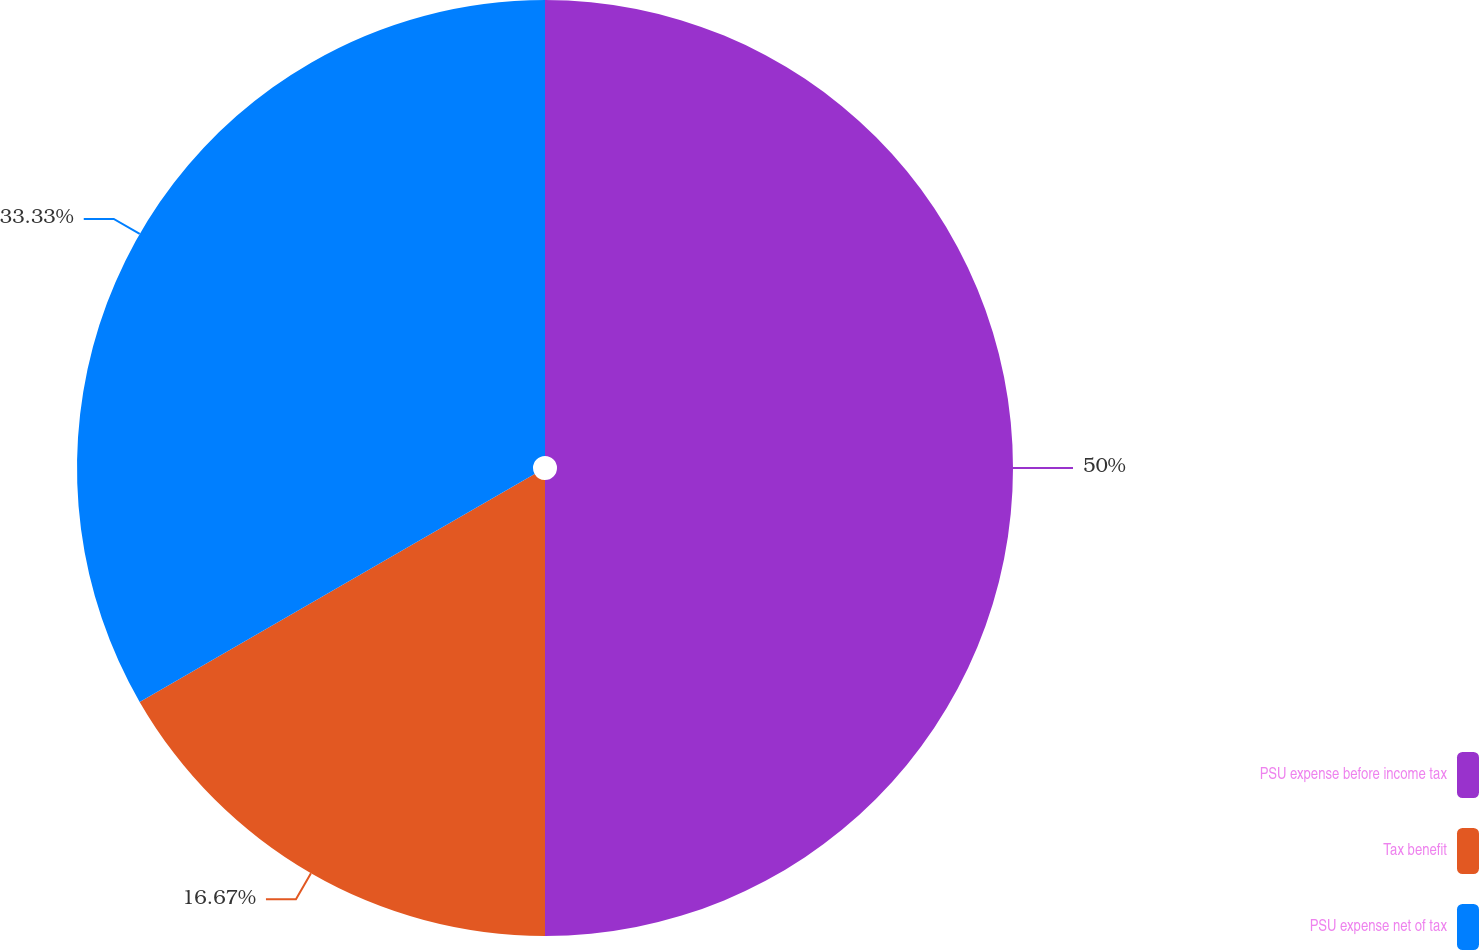Convert chart. <chart><loc_0><loc_0><loc_500><loc_500><pie_chart><fcel>PSU expense before income tax<fcel>Tax benefit<fcel>PSU expense net of tax<nl><fcel>50.0%<fcel>16.67%<fcel>33.33%<nl></chart> 